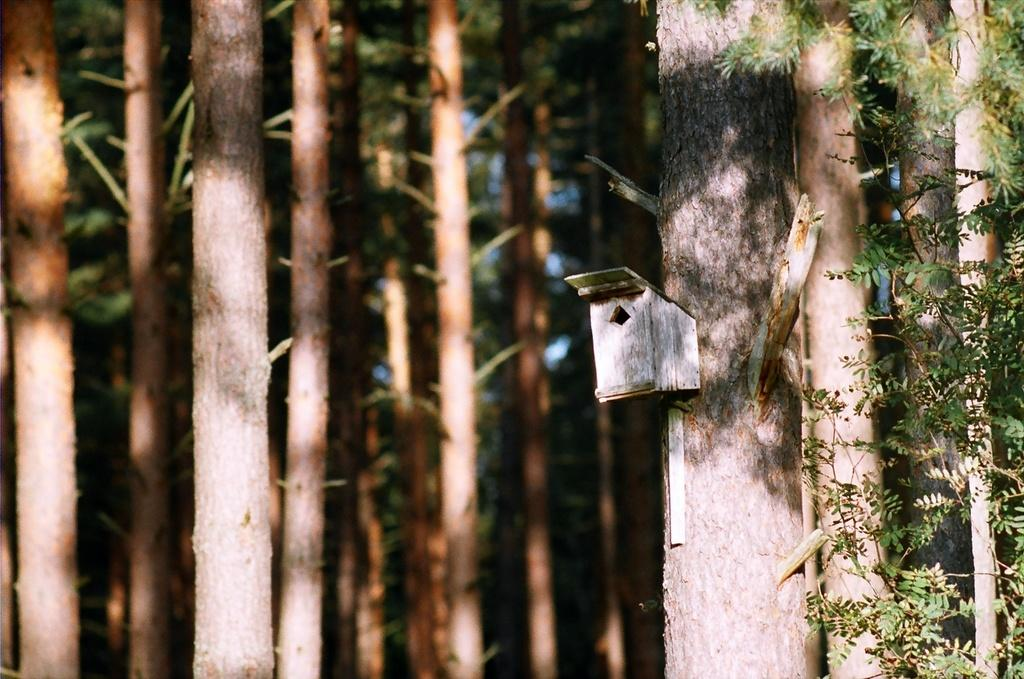What type of object is made of wood in the image? There is a wooden object in the image, but the specific type is not mentioned. What can be seen in the background of the image? There are trees in the background of the image. What type of pain can be felt by the wooden object in the image? There is no indication of pain or any living beings in the image, so it cannot be determined if the wooden object feels any pain. 